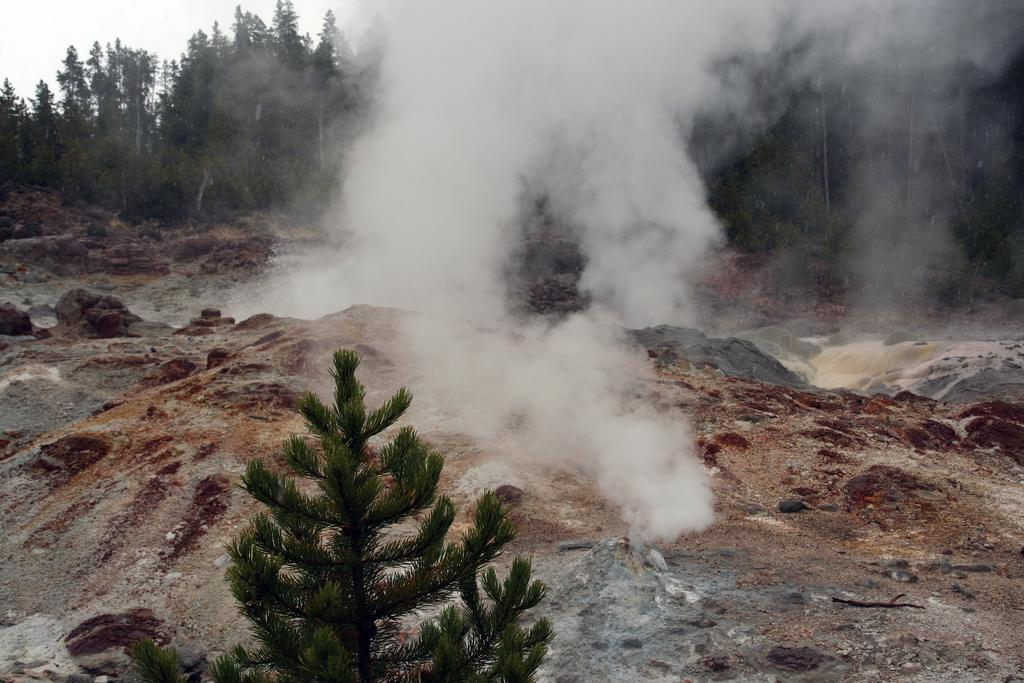What can be seen in the image that is not a part of the natural environment? There is smoke in the image. What type of plant is located at the bottom of the image? There is a small tree at the bottom of the image. What can be seen in the background of the image besides the sky? There are trees in the background of the image. What part of the natural environment is visible in the background of the image? The sky is visible in the background of the image. How many eyes can be seen on the small tree in the image? There are no eyes present on the small tree or any other part of the image. What type of tank is visible in the background of the image? There is no tank present in the image; it features smoke, a small tree, and trees in the background. 